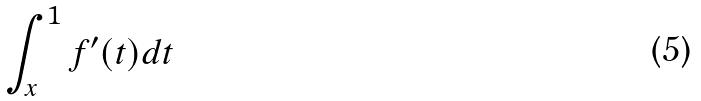Convert formula to latex. <formula><loc_0><loc_0><loc_500><loc_500>\int _ { x } ^ { 1 } f ^ { \prime } ( t ) d t</formula> 